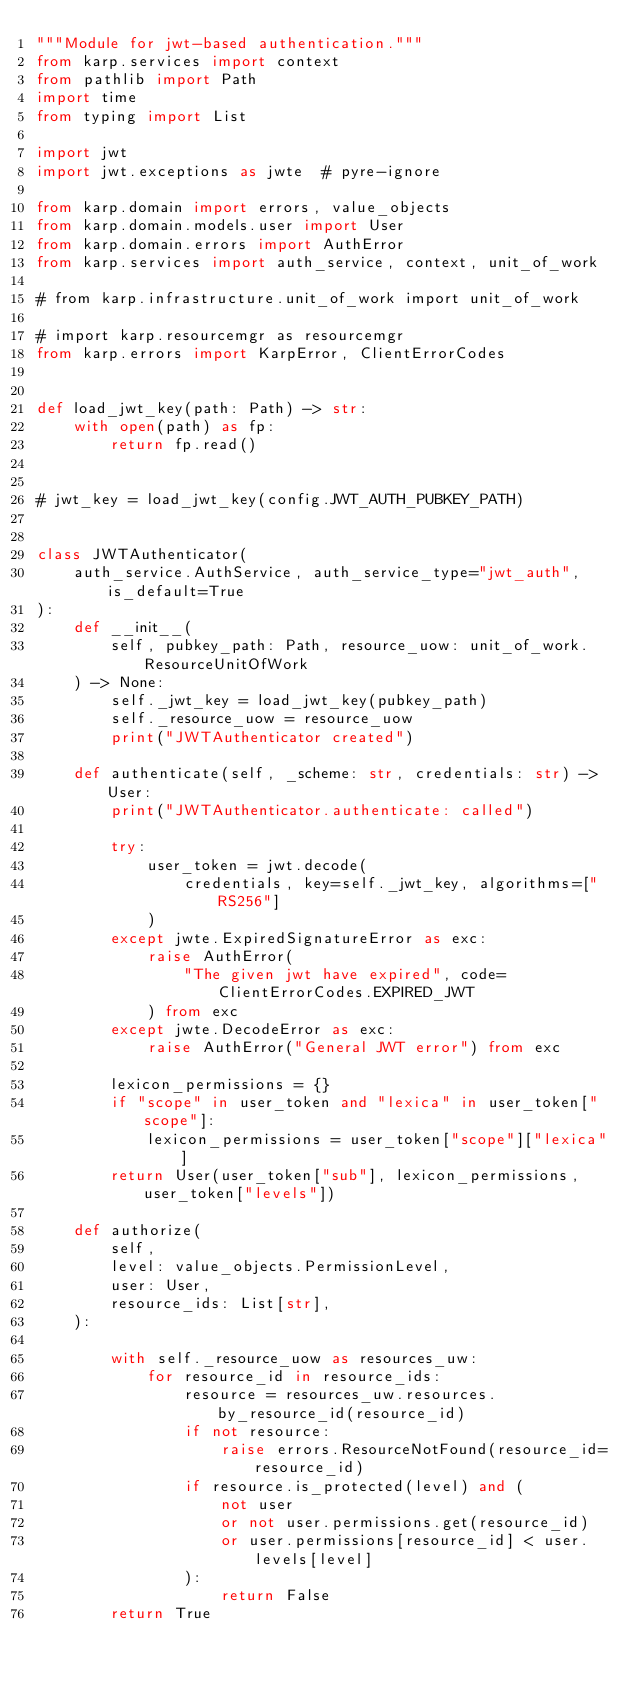<code> <loc_0><loc_0><loc_500><loc_500><_Python_>"""Module for jwt-based authentication."""
from karp.services import context
from pathlib import Path
import time
from typing import List

import jwt
import jwt.exceptions as jwte  # pyre-ignore

from karp.domain import errors, value_objects
from karp.domain.models.user import User
from karp.domain.errors import AuthError
from karp.services import auth_service, context, unit_of_work

# from karp.infrastructure.unit_of_work import unit_of_work

# import karp.resourcemgr as resourcemgr
from karp.errors import KarpError, ClientErrorCodes


def load_jwt_key(path: Path) -> str:
    with open(path) as fp:
        return fp.read()


# jwt_key = load_jwt_key(config.JWT_AUTH_PUBKEY_PATH)


class JWTAuthenticator(
    auth_service.AuthService, auth_service_type="jwt_auth", is_default=True
):
    def __init__(
        self, pubkey_path: Path, resource_uow: unit_of_work.ResourceUnitOfWork
    ) -> None:
        self._jwt_key = load_jwt_key(pubkey_path)
        self._resource_uow = resource_uow
        print("JWTAuthenticator created")

    def authenticate(self, _scheme: str, credentials: str) -> User:
        print("JWTAuthenticator.authenticate: called")

        try:
            user_token = jwt.decode(
                credentials, key=self._jwt_key, algorithms=["RS256"]
            )
        except jwte.ExpiredSignatureError as exc:
            raise AuthError(
                "The given jwt have expired", code=ClientErrorCodes.EXPIRED_JWT
            ) from exc
        except jwte.DecodeError as exc:
            raise AuthError("General JWT error") from exc

        lexicon_permissions = {}
        if "scope" in user_token and "lexica" in user_token["scope"]:
            lexicon_permissions = user_token["scope"]["lexica"]
        return User(user_token["sub"], lexicon_permissions, user_token["levels"])

    def authorize(
        self,
        level: value_objects.PermissionLevel,
        user: User,
        resource_ids: List[str],
    ):

        with self._resource_uow as resources_uw:
            for resource_id in resource_ids:
                resource = resources_uw.resources.by_resource_id(resource_id)
                if not resource:
                    raise errors.ResourceNotFound(resource_id=resource_id)
                if resource.is_protected(level) and (
                    not user
                    or not user.permissions.get(resource_id)
                    or user.permissions[resource_id] < user.levels[level]
                ):
                    return False
        return True
</code> 